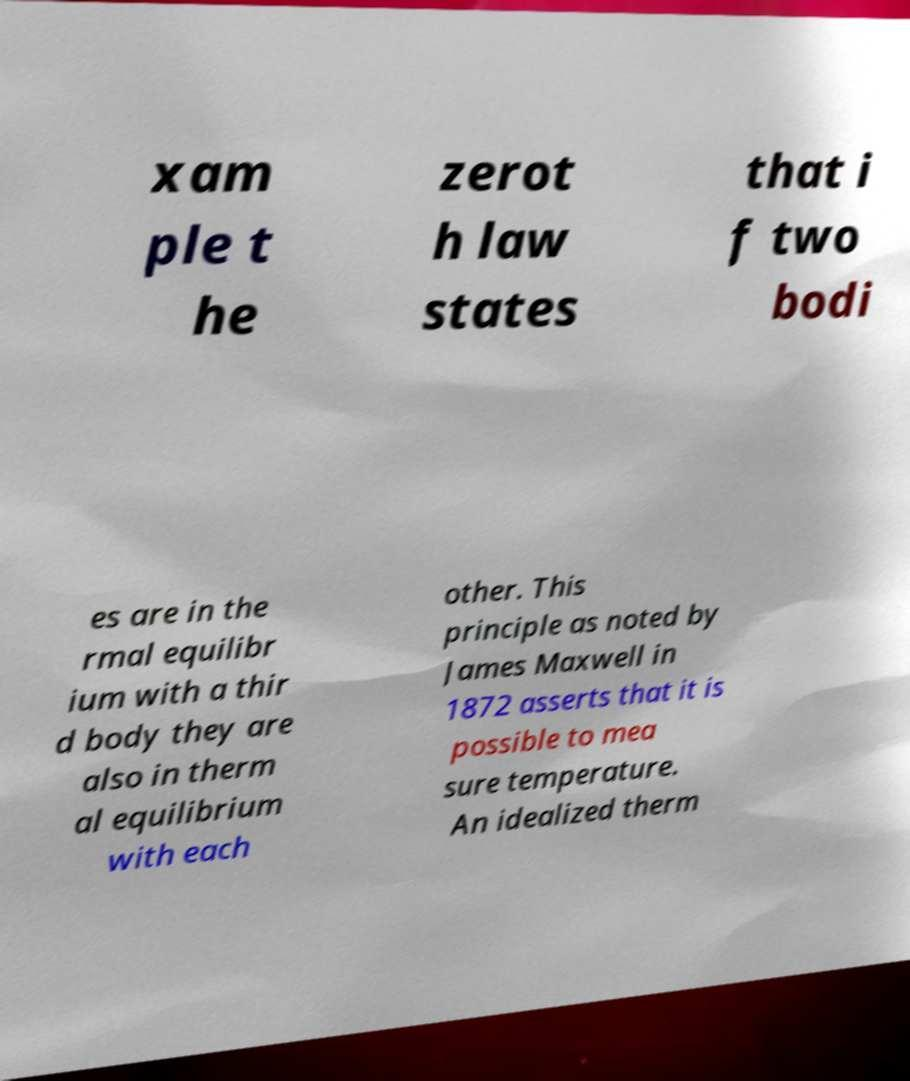There's text embedded in this image that I need extracted. Can you transcribe it verbatim? xam ple t he zerot h law states that i f two bodi es are in the rmal equilibr ium with a thir d body they are also in therm al equilibrium with each other. This principle as noted by James Maxwell in 1872 asserts that it is possible to mea sure temperature. An idealized therm 